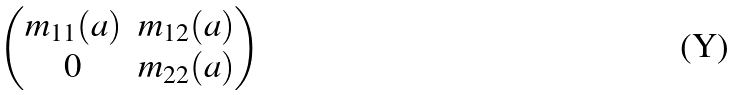<formula> <loc_0><loc_0><loc_500><loc_500>\begin{pmatrix} m _ { 1 1 } ( a ) & m _ { 1 2 } ( a ) \\ 0 & m _ { 2 2 } ( a ) \end{pmatrix}</formula> 